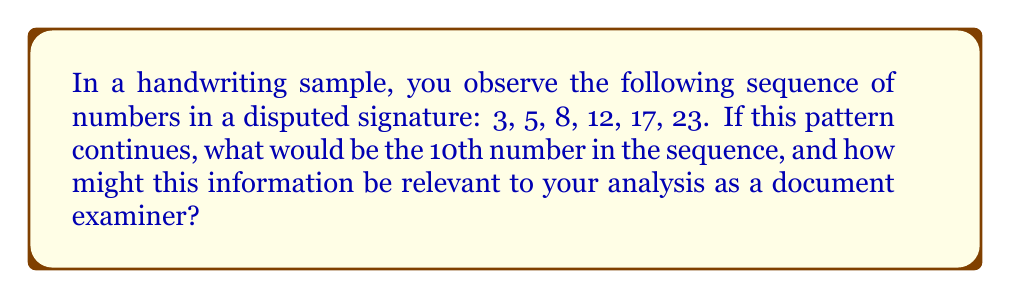Can you solve this math problem? To solve this problem and understand its relevance to document examination, let's follow these steps:

1. Analyze the pattern:
   First, calculate the differences between consecutive terms:
   $5 - 3 = 2$
   $8 - 5 = 3$
   $12 - 8 = 4$
   $17 - 12 = 5$
   $23 - 17 = 6$

2. Identify the sequence type:
   We observe that the differences form an arithmetic sequence: 2, 3, 4, 5, 6
   This indicates that the original sequence is a quadratic sequence.

3. Find the general term:
   For a quadratic sequence, the general term is of the form:
   $a_n = an^2 + bn + c$, where $n$ is the term number.

4. Determine the coefficients:
   Using the first three terms, we can set up a system of equations:
   $3 = a(1)^2 + b(1) + c$
   $5 = a(2)^2 + b(2) + c$
   $8 = a(3)^2 + b(3) + c$

   Solving this system yields: $a = 1$, $b = 0$, $c = 2$

5. Write the general term:
   $a_n = n^2 + 2$

6. Calculate the 10th term:
   $a_{10} = 10^2 + 2 = 102$

Relevance to document examination:
As a document examiner, identifying such numerical patterns in signatures can be crucial. Consistent patterns may indicate authenticity, while deviations could suggest forgery. The quadratic nature of this sequence might represent a unique characteristic of the signer's style, potentially related to stroke formation or spacing. This pattern could serve as a quantifiable feature for comparison with other samples or for detecting anomalies in disputed signatures.
Answer: 102 